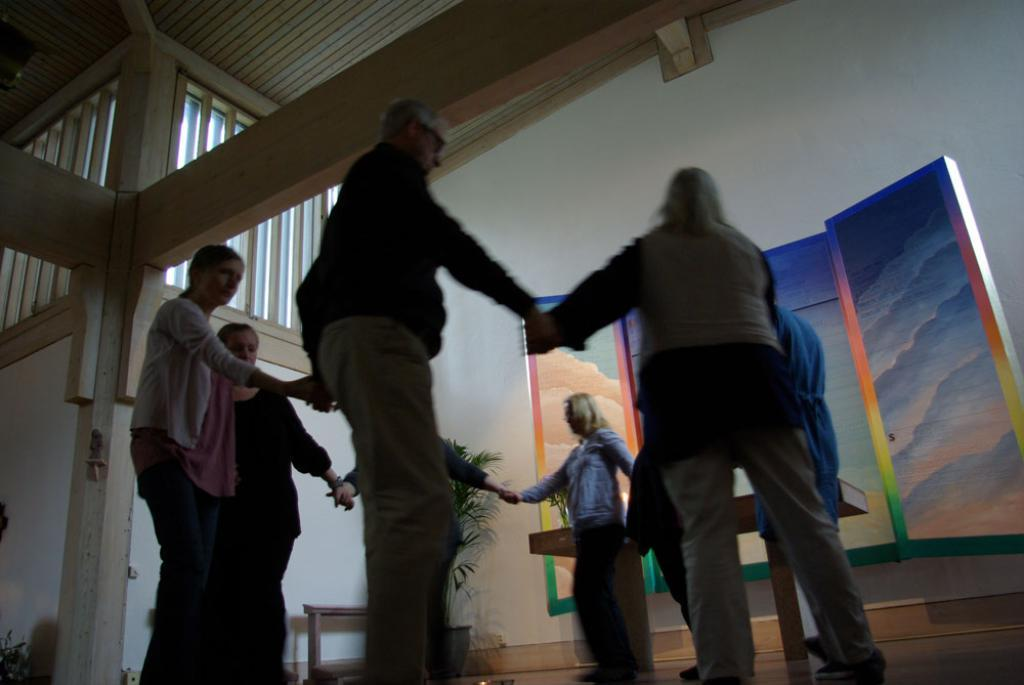What is happening in the image involving a group of people? There is a group of people in the image, and they are standing and holding their hands. How are the people arranged in the image? The people are standing in a circle. What can be seen in the background of the image? There are plants in the backdrop of the image. What type of lumber is being used to build the pot in the image? There is no pot or lumber present in the image. How does the group of people feel shame in the image? There is no indication of shame or any emotional state in the image; the people are simply standing and holding their hands. 